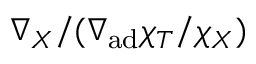Convert formula to latex. <formula><loc_0><loc_0><loc_500><loc_500>\nabla _ { X } / ( \nabla _ { a d } \chi _ { T } / \chi _ { X } )</formula> 